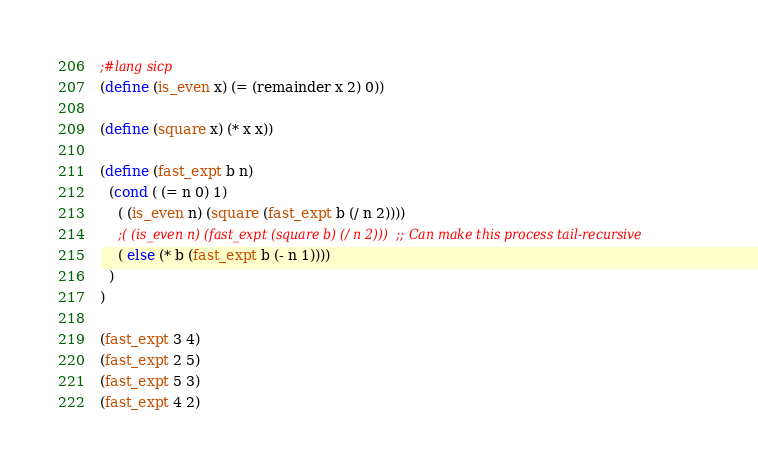<code> <loc_0><loc_0><loc_500><loc_500><_Scheme_>;#lang sicp
(define (is_even x) (= (remainder x 2) 0))

(define (square x) (* x x))

(define (fast_expt b n)
  (cond ( (= n 0) 1) 
	( (is_even n) (square (fast_expt b (/ n 2))))
	;( (is_even n) (fast_expt (square b) (/ n 2)))  ;; Can make this process tail-recursive
	( else (* b (fast_expt b (- n 1))))
  )
)

(fast_expt 3 4)
(fast_expt 2 5)
(fast_expt 5 3)
(fast_expt 4 2)
</code> 